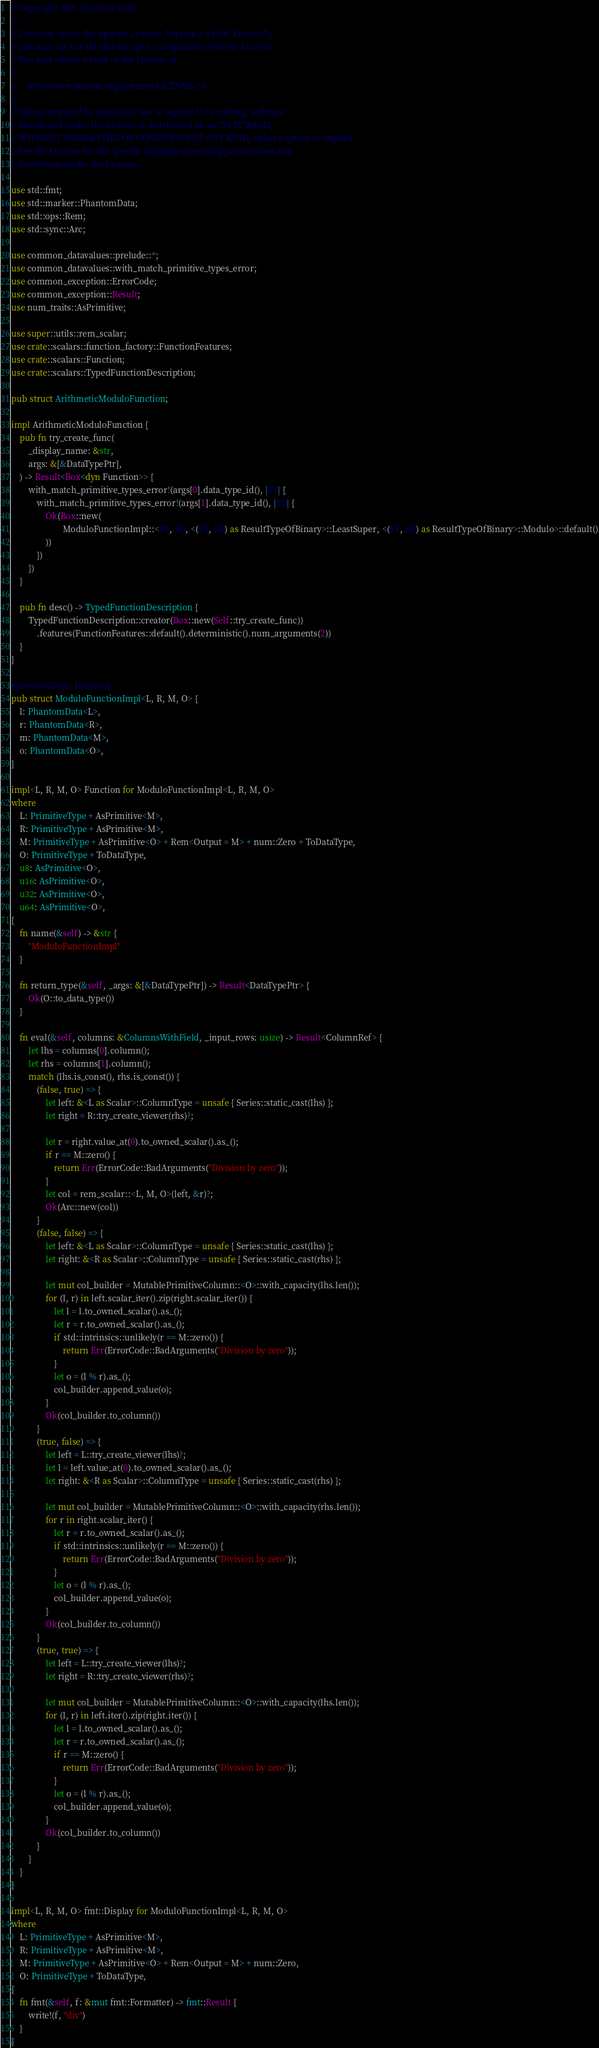Convert code to text. <code><loc_0><loc_0><loc_500><loc_500><_Rust_>// Copyright 2021 Datafuse Labs.
//
// Licensed under the Apache License, Version 2.0 (the "License");
// you may not use this file except in compliance with the License.
// You may obtain a copy of the License at
//
//     http://www.apache.org/licenses/LICENSE-2.0
//
// Unless required by applicable law or agreed to in writing, software
// distributed under the License is distributed on an "AS IS" BASIS,
// WITHOUT WARRANTIES OR CONDITIONS OF ANY KIND, either express or implied.
// See the License for the specific language governing permissions and
// limitations under the License.

use std::fmt;
use std::marker::PhantomData;
use std::ops::Rem;
use std::sync::Arc;

use common_datavalues::prelude::*;
use common_datavalues::with_match_primitive_types_error;
use common_exception::ErrorCode;
use common_exception::Result;
use num_traits::AsPrimitive;

use super::utils::rem_scalar;
use crate::scalars::function_factory::FunctionFeatures;
use crate::scalars::Function;
use crate::scalars::TypedFunctionDescription;

pub struct ArithmeticModuloFunction;

impl ArithmeticModuloFunction {
    pub fn try_create_func(
        _display_name: &str,
        args: &[&DataTypePtr],
    ) -> Result<Box<dyn Function>> {
        with_match_primitive_types_error!(args[0].data_type_id(), |$T| {
            with_match_primitive_types_error!(args[1].data_type_id(), |$D| {
                Ok(Box::new(
                        ModuloFunctionImpl::<$T, $D, <($T, $D) as ResultTypeOfBinary>::LeastSuper, <($T, $D) as ResultTypeOfBinary>::Modulo>::default()
                ))
            })
        })
    }

    pub fn desc() -> TypedFunctionDescription {
        TypedFunctionDescription::creator(Box::new(Self::try_create_func))
            .features(FunctionFeatures::default().deterministic().num_arguments(2))
    }
}

#[derive(Clone, Default)]
pub struct ModuloFunctionImpl<L, R, M, O> {
    l: PhantomData<L>,
    r: PhantomData<R>,
    m: PhantomData<M>,
    o: PhantomData<O>,
}

impl<L, R, M, O> Function for ModuloFunctionImpl<L, R, M, O>
where
    L: PrimitiveType + AsPrimitive<M>,
    R: PrimitiveType + AsPrimitive<M>,
    M: PrimitiveType + AsPrimitive<O> + Rem<Output = M> + num::Zero + ToDataType,
    O: PrimitiveType + ToDataType,
    u8: AsPrimitive<O>,
    u16: AsPrimitive<O>,
    u32: AsPrimitive<O>,
    u64: AsPrimitive<O>,
{
    fn name(&self) -> &str {
        "ModuloFunctionImpl"
    }

    fn return_type(&self, _args: &[&DataTypePtr]) -> Result<DataTypePtr> {
        Ok(O::to_data_type())
    }

    fn eval(&self, columns: &ColumnsWithField, _input_rows: usize) -> Result<ColumnRef> {
        let lhs = columns[0].column();
        let rhs = columns[1].column();
        match (lhs.is_const(), rhs.is_const()) {
            (false, true) => {
                let left: &<L as Scalar>::ColumnType = unsafe { Series::static_cast(lhs) };
                let right = R::try_create_viewer(rhs)?;

                let r = right.value_at(0).to_owned_scalar().as_();
                if r == M::zero() {
                    return Err(ErrorCode::BadArguments("Division by zero"));
                }
                let col = rem_scalar::<L, M, O>(left, &r)?;
                Ok(Arc::new(col))
            }
            (false, false) => {
                let left: &<L as Scalar>::ColumnType = unsafe { Series::static_cast(lhs) };
                let right: &<R as Scalar>::ColumnType = unsafe { Series::static_cast(rhs) };

                let mut col_builder = MutablePrimitiveColumn::<O>::with_capacity(lhs.len());
                for (l, r) in left.scalar_iter().zip(right.scalar_iter()) {
                    let l = l.to_owned_scalar().as_();
                    let r = r.to_owned_scalar().as_();
                    if std::intrinsics::unlikely(r == M::zero()) {
                        return Err(ErrorCode::BadArguments("Division by zero"));
                    }
                    let o = (l % r).as_();
                    col_builder.append_value(o);
                }
                Ok(col_builder.to_column())
            }
            (true, false) => {
                let left = L::try_create_viewer(lhs)?;
                let l = left.value_at(0).to_owned_scalar().as_();
                let right: &<R as Scalar>::ColumnType = unsafe { Series::static_cast(rhs) };

                let mut col_builder = MutablePrimitiveColumn::<O>::with_capacity(rhs.len());
                for r in right.scalar_iter() {
                    let r = r.to_owned_scalar().as_();
                    if std::intrinsics::unlikely(r == M::zero()) {
                        return Err(ErrorCode::BadArguments("Division by zero"));
                    }
                    let o = (l % r).as_();
                    col_builder.append_value(o);
                }
                Ok(col_builder.to_column())
            }
            (true, true) => {
                let left = L::try_create_viewer(lhs)?;
                let right = R::try_create_viewer(rhs)?;

                let mut col_builder = MutablePrimitiveColumn::<O>::with_capacity(lhs.len());
                for (l, r) in left.iter().zip(right.iter()) {
                    let l = l.to_owned_scalar().as_();
                    let r = r.to_owned_scalar().as_();
                    if r == M::zero() {
                        return Err(ErrorCode::BadArguments("Division by zero"));
                    }
                    let o = (l % r).as_();
                    col_builder.append_value(o);
                }
                Ok(col_builder.to_column())
            }
        }
    }
}

impl<L, R, M, O> fmt::Display for ModuloFunctionImpl<L, R, M, O>
where
    L: PrimitiveType + AsPrimitive<M>,
    R: PrimitiveType + AsPrimitive<M>,
    M: PrimitiveType + AsPrimitive<O> + Rem<Output = M> + num::Zero,
    O: PrimitiveType + ToDataType,
{
    fn fmt(&self, f: &mut fmt::Formatter) -> fmt::Result {
        write!(f, "div")
    }
}
</code> 